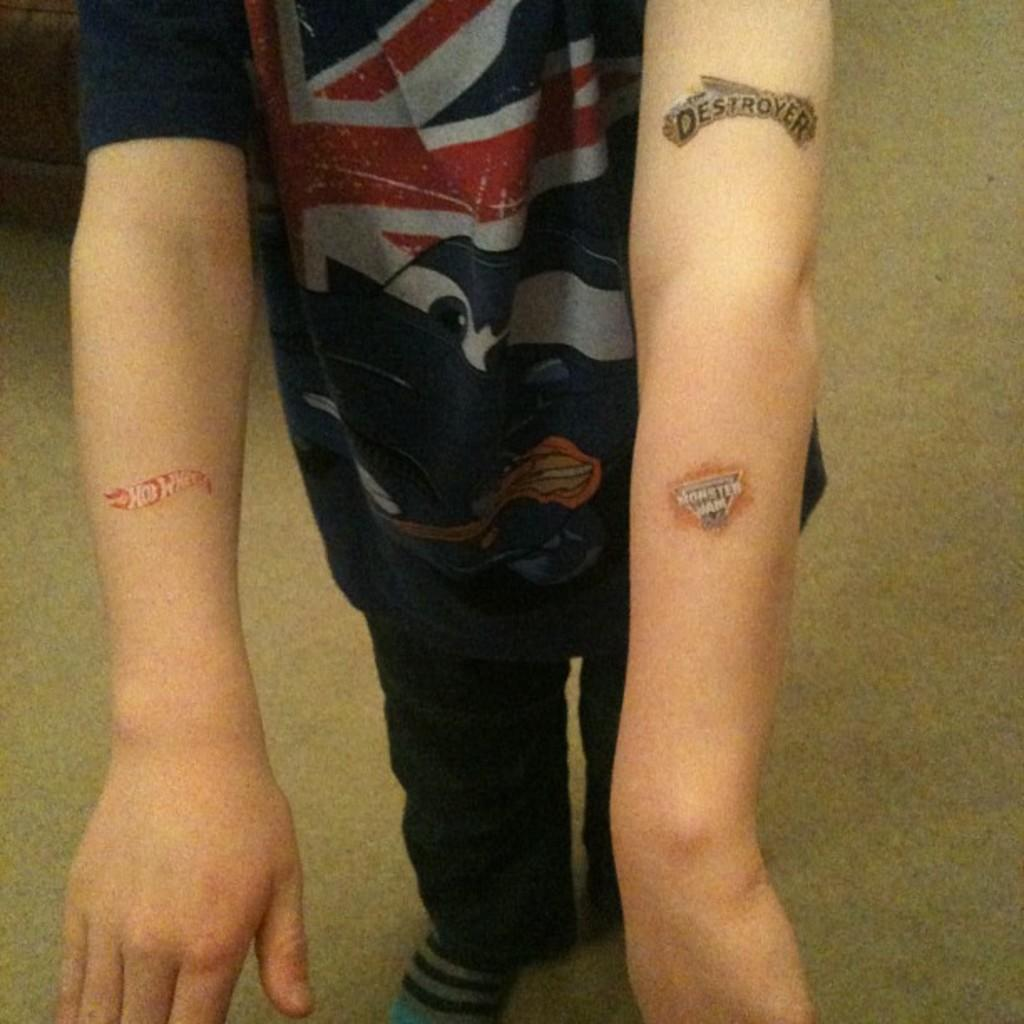<image>
Relay a brief, clear account of the picture shown. A kid with temporary tattoos that say Hot Wheels, Monster Jam and Destroyer. 